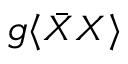<formula> <loc_0><loc_0><loc_500><loc_500>g \langle { \bar { X } } X \rangle</formula> 